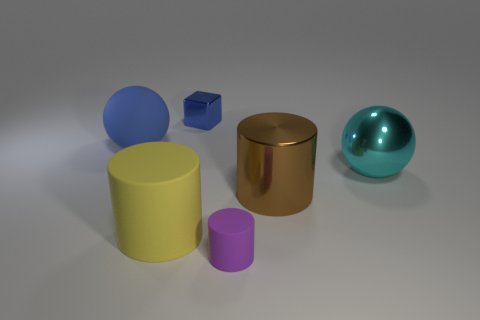Add 3 small yellow shiny objects. How many objects exist? 9 Subtract all blocks. How many objects are left? 5 Add 6 tiny blue metallic objects. How many tiny blue metallic objects are left? 7 Add 4 tiny metal blocks. How many tiny metal blocks exist? 5 Subtract 0 cyan cubes. How many objects are left? 6 Subtract all big brown things. Subtract all purple rubber cylinders. How many objects are left? 4 